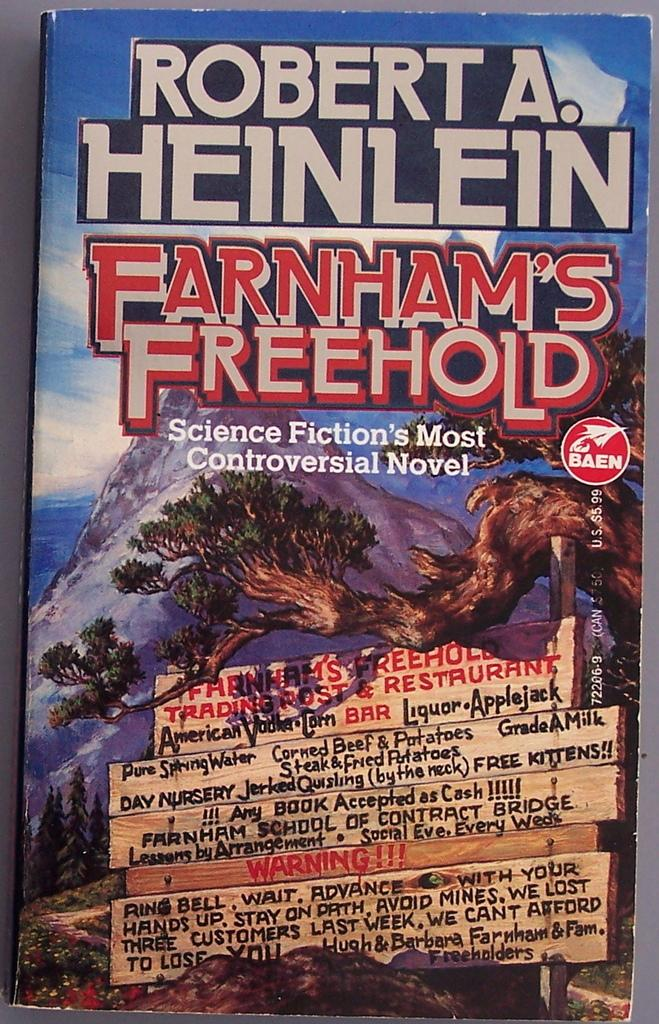<image>
Describe the image concisely. A science fiction book is titled Farnham's Freehold. 